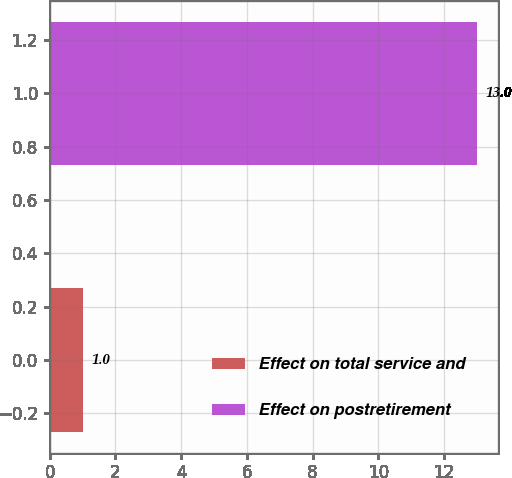Convert chart. <chart><loc_0><loc_0><loc_500><loc_500><bar_chart><fcel>Effect on total service and<fcel>Effect on postretirement<nl><fcel>1<fcel>13<nl></chart> 